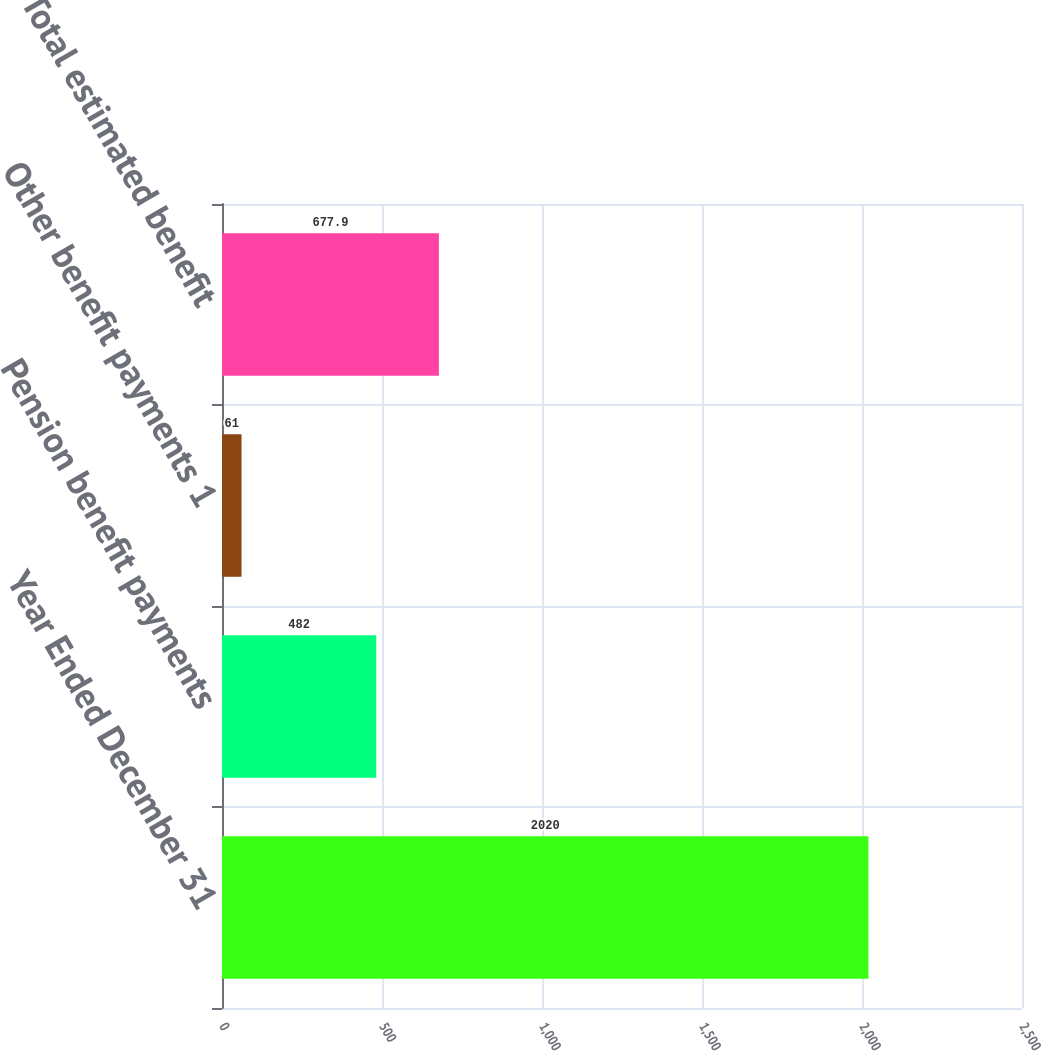Convert chart to OTSL. <chart><loc_0><loc_0><loc_500><loc_500><bar_chart><fcel>Year Ended December 31<fcel>Pension benefit payments<fcel>Other benefit payments 1<fcel>Total estimated benefit<nl><fcel>2020<fcel>482<fcel>61<fcel>677.9<nl></chart> 